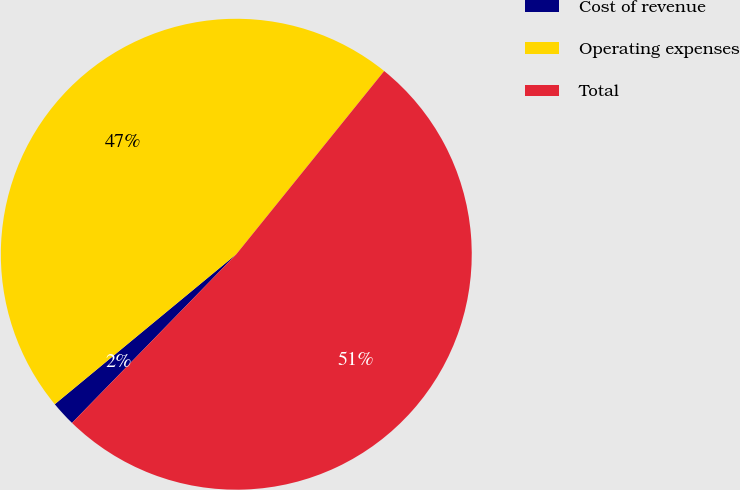Convert chart to OTSL. <chart><loc_0><loc_0><loc_500><loc_500><pie_chart><fcel>Cost of revenue<fcel>Operating expenses<fcel>Total<nl><fcel>1.72%<fcel>46.8%<fcel>51.48%<nl></chart> 